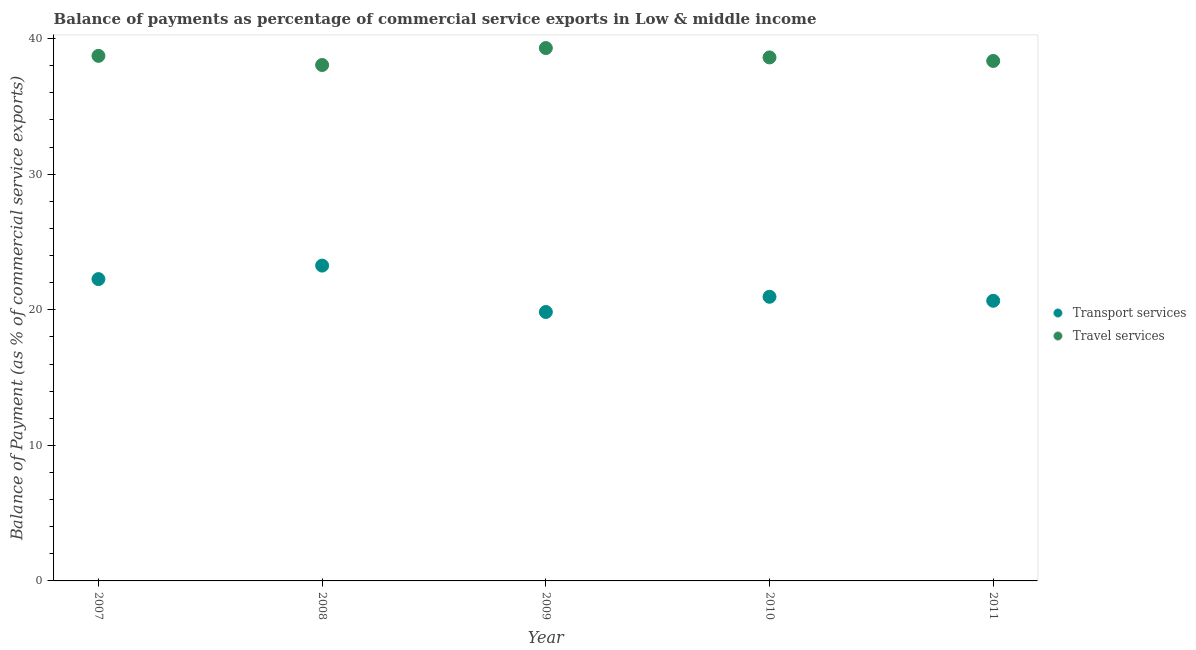Is the number of dotlines equal to the number of legend labels?
Ensure brevity in your answer.  Yes. What is the balance of payments of transport services in 2009?
Keep it short and to the point. 19.84. Across all years, what is the maximum balance of payments of transport services?
Provide a short and direct response. 23.26. Across all years, what is the minimum balance of payments of travel services?
Keep it short and to the point. 38.06. In which year was the balance of payments of transport services maximum?
Your answer should be compact. 2008. What is the total balance of payments of transport services in the graph?
Provide a succinct answer. 106.98. What is the difference between the balance of payments of transport services in 2008 and that in 2010?
Make the answer very short. 2.3. What is the difference between the balance of payments of transport services in 2011 and the balance of payments of travel services in 2010?
Offer a terse response. -17.95. What is the average balance of payments of travel services per year?
Offer a terse response. 38.61. In the year 2011, what is the difference between the balance of payments of travel services and balance of payments of transport services?
Your response must be concise. 17.69. In how many years, is the balance of payments of transport services greater than 18 %?
Offer a terse response. 5. What is the ratio of the balance of payments of transport services in 2008 to that in 2009?
Your answer should be compact. 1.17. Is the balance of payments of travel services in 2009 less than that in 2011?
Ensure brevity in your answer.  No. What is the difference between the highest and the second highest balance of payments of travel services?
Offer a very short reply. 0.57. What is the difference between the highest and the lowest balance of payments of transport services?
Your answer should be compact. 3.42. Does the balance of payments of travel services monotonically increase over the years?
Provide a succinct answer. No. Is the balance of payments of transport services strictly less than the balance of payments of travel services over the years?
Ensure brevity in your answer.  Yes. How many years are there in the graph?
Make the answer very short. 5. What is the difference between two consecutive major ticks on the Y-axis?
Your answer should be very brief. 10. Are the values on the major ticks of Y-axis written in scientific E-notation?
Offer a very short reply. No. Does the graph contain any zero values?
Your answer should be very brief. No. What is the title of the graph?
Provide a short and direct response. Balance of payments as percentage of commercial service exports in Low & middle income. Does "Resident workers" appear as one of the legend labels in the graph?
Your answer should be very brief. No. What is the label or title of the Y-axis?
Ensure brevity in your answer.  Balance of Payment (as % of commercial service exports). What is the Balance of Payment (as % of commercial service exports) in Transport services in 2007?
Provide a short and direct response. 22.26. What is the Balance of Payment (as % of commercial service exports) in Travel services in 2007?
Keep it short and to the point. 38.73. What is the Balance of Payment (as % of commercial service exports) in Transport services in 2008?
Offer a very short reply. 23.26. What is the Balance of Payment (as % of commercial service exports) in Travel services in 2008?
Make the answer very short. 38.06. What is the Balance of Payment (as % of commercial service exports) of Transport services in 2009?
Your response must be concise. 19.84. What is the Balance of Payment (as % of commercial service exports) of Travel services in 2009?
Your answer should be compact. 39.3. What is the Balance of Payment (as % of commercial service exports) in Transport services in 2010?
Give a very brief answer. 20.96. What is the Balance of Payment (as % of commercial service exports) in Travel services in 2010?
Keep it short and to the point. 38.61. What is the Balance of Payment (as % of commercial service exports) of Transport services in 2011?
Ensure brevity in your answer.  20.66. What is the Balance of Payment (as % of commercial service exports) in Travel services in 2011?
Keep it short and to the point. 38.35. Across all years, what is the maximum Balance of Payment (as % of commercial service exports) of Transport services?
Ensure brevity in your answer.  23.26. Across all years, what is the maximum Balance of Payment (as % of commercial service exports) of Travel services?
Offer a terse response. 39.3. Across all years, what is the minimum Balance of Payment (as % of commercial service exports) in Transport services?
Give a very brief answer. 19.84. Across all years, what is the minimum Balance of Payment (as % of commercial service exports) in Travel services?
Your answer should be compact. 38.06. What is the total Balance of Payment (as % of commercial service exports) of Transport services in the graph?
Your answer should be very brief. 106.98. What is the total Balance of Payment (as % of commercial service exports) in Travel services in the graph?
Your answer should be compact. 193.06. What is the difference between the Balance of Payment (as % of commercial service exports) in Transport services in 2007 and that in 2008?
Keep it short and to the point. -1. What is the difference between the Balance of Payment (as % of commercial service exports) in Travel services in 2007 and that in 2008?
Offer a terse response. 0.67. What is the difference between the Balance of Payment (as % of commercial service exports) in Transport services in 2007 and that in 2009?
Keep it short and to the point. 2.43. What is the difference between the Balance of Payment (as % of commercial service exports) in Travel services in 2007 and that in 2009?
Offer a terse response. -0.57. What is the difference between the Balance of Payment (as % of commercial service exports) of Transport services in 2007 and that in 2010?
Your answer should be very brief. 1.3. What is the difference between the Balance of Payment (as % of commercial service exports) in Travel services in 2007 and that in 2010?
Ensure brevity in your answer.  0.12. What is the difference between the Balance of Payment (as % of commercial service exports) in Transport services in 2007 and that in 2011?
Keep it short and to the point. 1.6. What is the difference between the Balance of Payment (as % of commercial service exports) in Travel services in 2007 and that in 2011?
Ensure brevity in your answer.  0.38. What is the difference between the Balance of Payment (as % of commercial service exports) of Transport services in 2008 and that in 2009?
Give a very brief answer. 3.42. What is the difference between the Balance of Payment (as % of commercial service exports) of Travel services in 2008 and that in 2009?
Provide a short and direct response. -1.25. What is the difference between the Balance of Payment (as % of commercial service exports) of Transport services in 2008 and that in 2010?
Your response must be concise. 2.3. What is the difference between the Balance of Payment (as % of commercial service exports) of Travel services in 2008 and that in 2010?
Make the answer very short. -0.56. What is the difference between the Balance of Payment (as % of commercial service exports) in Transport services in 2008 and that in 2011?
Provide a short and direct response. 2.6. What is the difference between the Balance of Payment (as % of commercial service exports) of Travel services in 2008 and that in 2011?
Give a very brief answer. -0.3. What is the difference between the Balance of Payment (as % of commercial service exports) of Transport services in 2009 and that in 2010?
Provide a succinct answer. -1.12. What is the difference between the Balance of Payment (as % of commercial service exports) in Travel services in 2009 and that in 2010?
Your answer should be compact. 0.69. What is the difference between the Balance of Payment (as % of commercial service exports) of Transport services in 2009 and that in 2011?
Offer a very short reply. -0.83. What is the difference between the Balance of Payment (as % of commercial service exports) in Travel services in 2009 and that in 2011?
Make the answer very short. 0.95. What is the difference between the Balance of Payment (as % of commercial service exports) in Transport services in 2010 and that in 2011?
Your response must be concise. 0.29. What is the difference between the Balance of Payment (as % of commercial service exports) of Travel services in 2010 and that in 2011?
Keep it short and to the point. 0.26. What is the difference between the Balance of Payment (as % of commercial service exports) of Transport services in 2007 and the Balance of Payment (as % of commercial service exports) of Travel services in 2008?
Offer a terse response. -15.79. What is the difference between the Balance of Payment (as % of commercial service exports) in Transport services in 2007 and the Balance of Payment (as % of commercial service exports) in Travel services in 2009?
Offer a very short reply. -17.04. What is the difference between the Balance of Payment (as % of commercial service exports) of Transport services in 2007 and the Balance of Payment (as % of commercial service exports) of Travel services in 2010?
Ensure brevity in your answer.  -16.35. What is the difference between the Balance of Payment (as % of commercial service exports) in Transport services in 2007 and the Balance of Payment (as % of commercial service exports) in Travel services in 2011?
Provide a succinct answer. -16.09. What is the difference between the Balance of Payment (as % of commercial service exports) of Transport services in 2008 and the Balance of Payment (as % of commercial service exports) of Travel services in 2009?
Keep it short and to the point. -16.04. What is the difference between the Balance of Payment (as % of commercial service exports) in Transport services in 2008 and the Balance of Payment (as % of commercial service exports) in Travel services in 2010?
Ensure brevity in your answer.  -15.36. What is the difference between the Balance of Payment (as % of commercial service exports) of Transport services in 2008 and the Balance of Payment (as % of commercial service exports) of Travel services in 2011?
Keep it short and to the point. -15.1. What is the difference between the Balance of Payment (as % of commercial service exports) in Transport services in 2009 and the Balance of Payment (as % of commercial service exports) in Travel services in 2010?
Offer a very short reply. -18.78. What is the difference between the Balance of Payment (as % of commercial service exports) of Transport services in 2009 and the Balance of Payment (as % of commercial service exports) of Travel services in 2011?
Your response must be concise. -18.52. What is the difference between the Balance of Payment (as % of commercial service exports) of Transport services in 2010 and the Balance of Payment (as % of commercial service exports) of Travel services in 2011?
Your answer should be compact. -17.4. What is the average Balance of Payment (as % of commercial service exports) in Transport services per year?
Make the answer very short. 21.4. What is the average Balance of Payment (as % of commercial service exports) of Travel services per year?
Ensure brevity in your answer.  38.61. In the year 2007, what is the difference between the Balance of Payment (as % of commercial service exports) of Transport services and Balance of Payment (as % of commercial service exports) of Travel services?
Ensure brevity in your answer.  -16.47. In the year 2008, what is the difference between the Balance of Payment (as % of commercial service exports) of Transport services and Balance of Payment (as % of commercial service exports) of Travel services?
Provide a succinct answer. -14.8. In the year 2009, what is the difference between the Balance of Payment (as % of commercial service exports) of Transport services and Balance of Payment (as % of commercial service exports) of Travel services?
Provide a short and direct response. -19.47. In the year 2010, what is the difference between the Balance of Payment (as % of commercial service exports) in Transport services and Balance of Payment (as % of commercial service exports) in Travel services?
Provide a short and direct response. -17.66. In the year 2011, what is the difference between the Balance of Payment (as % of commercial service exports) in Transport services and Balance of Payment (as % of commercial service exports) in Travel services?
Offer a very short reply. -17.69. What is the ratio of the Balance of Payment (as % of commercial service exports) of Transport services in 2007 to that in 2008?
Your answer should be compact. 0.96. What is the ratio of the Balance of Payment (as % of commercial service exports) in Travel services in 2007 to that in 2008?
Offer a terse response. 1.02. What is the ratio of the Balance of Payment (as % of commercial service exports) in Transport services in 2007 to that in 2009?
Ensure brevity in your answer.  1.12. What is the ratio of the Balance of Payment (as % of commercial service exports) of Travel services in 2007 to that in 2009?
Your response must be concise. 0.99. What is the ratio of the Balance of Payment (as % of commercial service exports) in Transport services in 2007 to that in 2010?
Offer a terse response. 1.06. What is the ratio of the Balance of Payment (as % of commercial service exports) of Travel services in 2007 to that in 2010?
Provide a short and direct response. 1. What is the ratio of the Balance of Payment (as % of commercial service exports) in Transport services in 2007 to that in 2011?
Your response must be concise. 1.08. What is the ratio of the Balance of Payment (as % of commercial service exports) of Travel services in 2007 to that in 2011?
Make the answer very short. 1.01. What is the ratio of the Balance of Payment (as % of commercial service exports) in Transport services in 2008 to that in 2009?
Make the answer very short. 1.17. What is the ratio of the Balance of Payment (as % of commercial service exports) in Travel services in 2008 to that in 2009?
Your response must be concise. 0.97. What is the ratio of the Balance of Payment (as % of commercial service exports) in Transport services in 2008 to that in 2010?
Your response must be concise. 1.11. What is the ratio of the Balance of Payment (as % of commercial service exports) in Travel services in 2008 to that in 2010?
Your response must be concise. 0.99. What is the ratio of the Balance of Payment (as % of commercial service exports) of Transport services in 2008 to that in 2011?
Offer a terse response. 1.13. What is the ratio of the Balance of Payment (as % of commercial service exports) of Transport services in 2009 to that in 2010?
Your answer should be very brief. 0.95. What is the ratio of the Balance of Payment (as % of commercial service exports) of Travel services in 2009 to that in 2010?
Your answer should be very brief. 1.02. What is the ratio of the Balance of Payment (as % of commercial service exports) of Transport services in 2009 to that in 2011?
Provide a short and direct response. 0.96. What is the ratio of the Balance of Payment (as % of commercial service exports) of Travel services in 2009 to that in 2011?
Your answer should be compact. 1.02. What is the ratio of the Balance of Payment (as % of commercial service exports) of Transport services in 2010 to that in 2011?
Your answer should be compact. 1.01. What is the ratio of the Balance of Payment (as % of commercial service exports) in Travel services in 2010 to that in 2011?
Your answer should be very brief. 1.01. What is the difference between the highest and the second highest Balance of Payment (as % of commercial service exports) of Transport services?
Provide a short and direct response. 1. What is the difference between the highest and the second highest Balance of Payment (as % of commercial service exports) in Travel services?
Your answer should be compact. 0.57. What is the difference between the highest and the lowest Balance of Payment (as % of commercial service exports) in Transport services?
Give a very brief answer. 3.42. What is the difference between the highest and the lowest Balance of Payment (as % of commercial service exports) in Travel services?
Offer a terse response. 1.25. 